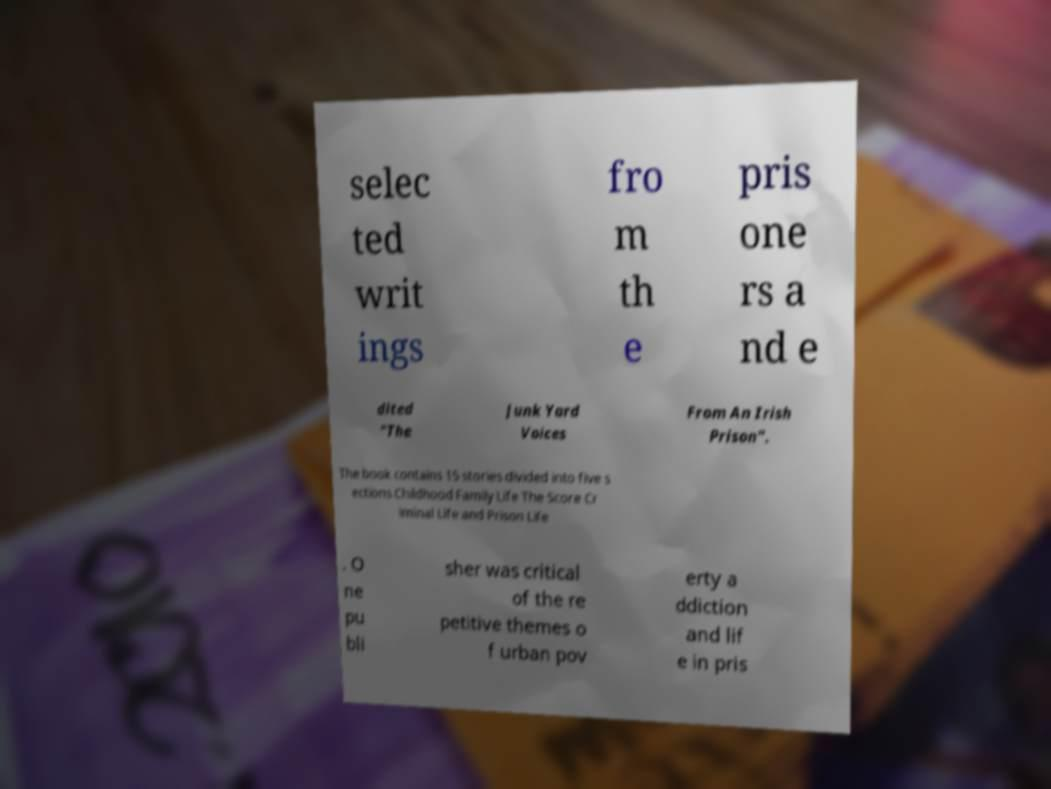I need the written content from this picture converted into text. Can you do that? selec ted writ ings fro m th e pris one rs a nd e dited "The Junk Yard Voices From An Irish Prison". The book contains 15 stories divided into five s ections Childhood Family Life The Score Cr iminal Life and Prison Life . O ne pu bli sher was critical of the re petitive themes o f urban pov erty a ddiction and lif e in pris 